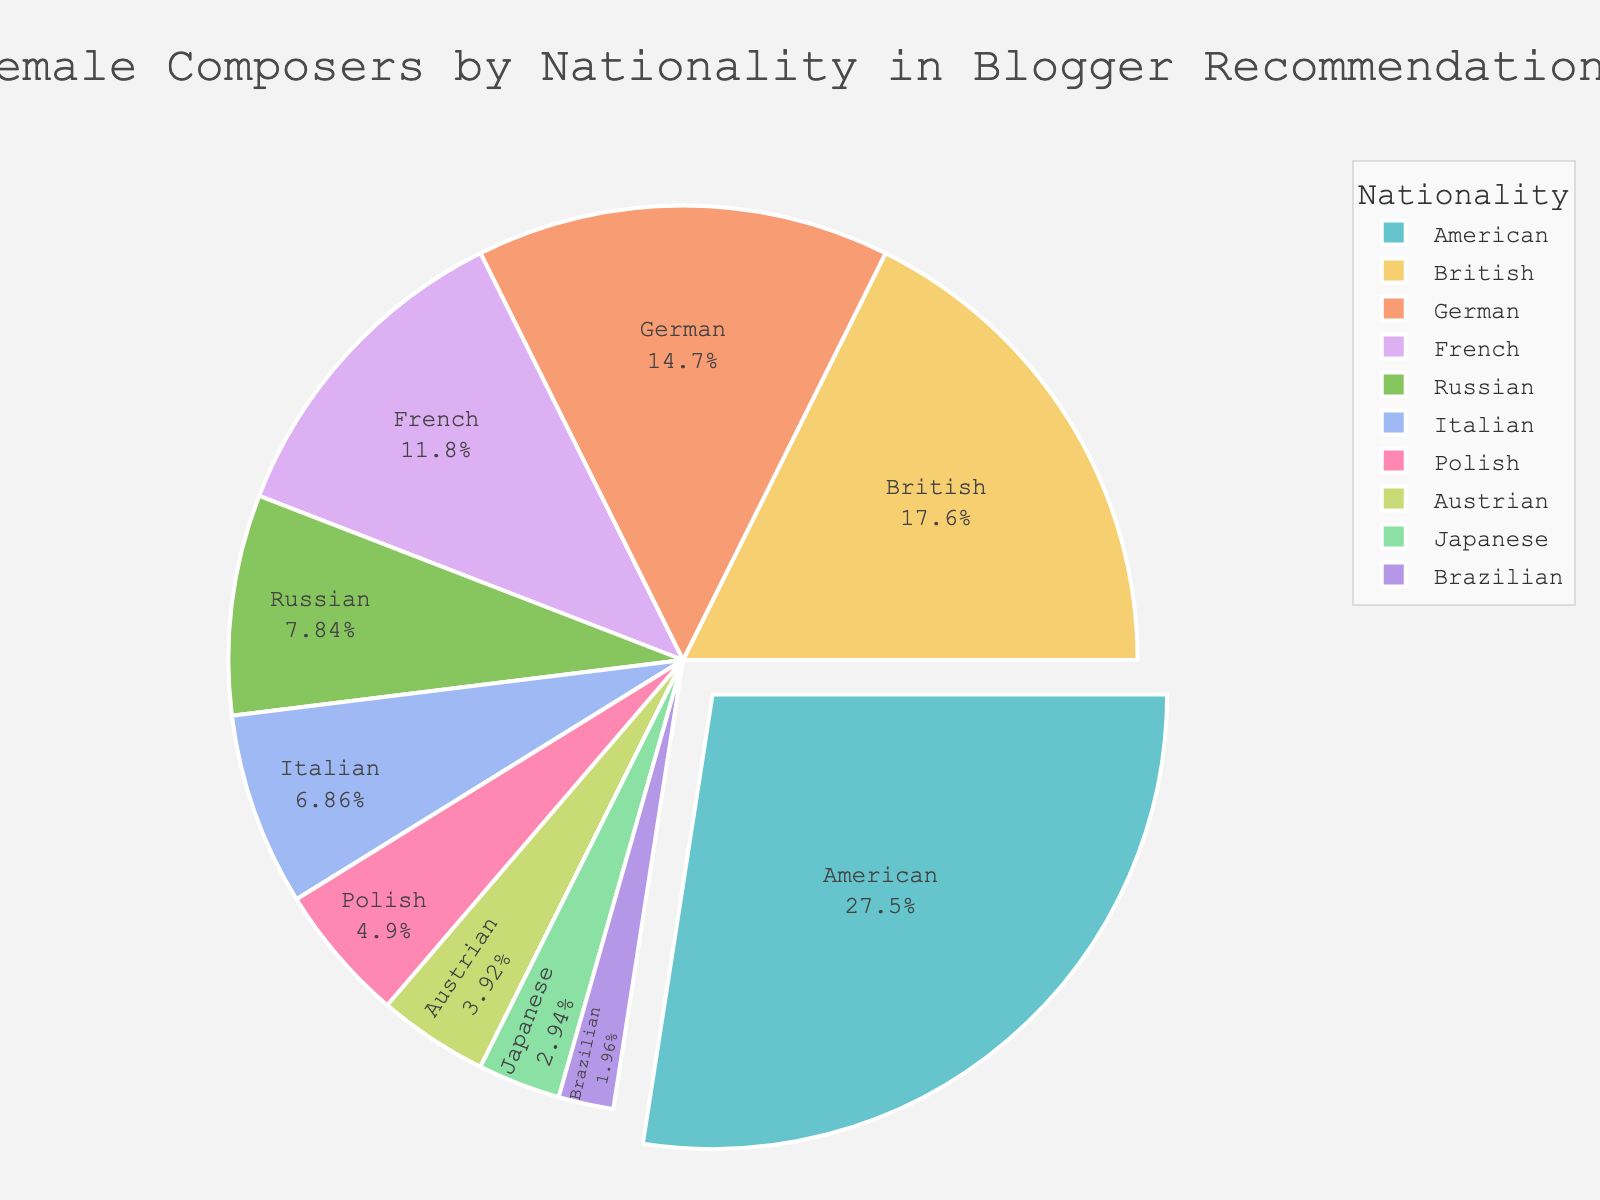How many nationalities together make up more than 60% of the recommendations? Add the percentages of the nationalities starting from the highest until the sum exceeds 60%. American (28%) + British (18%) + German (15%) = 61%
Answer: 3 Which nationality has the highest percentage of female composers in the recommendations? Refer to the nationality with the largest segment in the pie chart. The nationality with 28% is American
Answer: American What is the percentage difference between German and French composers? Subtract the percentage of French composers from German composers. 15% - 12% = 3%
Answer: 3% Are there more Russian or Italian female composers recommended? Compare the percentages for Russian and Italian composers. Russian is 8%, and Italian is 7%; thus, Russian is larger
Answer: Russian What is the combined percentage of Polish, Austrian, Japanese, and Brazilian composers? Add the percentages of these four nationalities. 5% (Polish) + 4% (Austrian) + 3% (Japanese) + 2% (Brazilian) = 14%
Answer: 14% If you were to combine American and British composers, what percentage of the total would they represent? Add the percentages of American and British composers. 28% (American) + 18% (British) = 46%
Answer: 46% Which nationality has the smallest representation in the recommendations? Look for the nationality with the smallest segment in the pie chart. The smallest percentage is 2%, which is Brazilian
Answer: Brazilian What is the percentage range of the nationalities represented in the recommendations? Subtract the smallest percentage from the largest percentage. 28% (largest, American) - 2% (smallest, Brazilian) = 26%
Answer: 26% What is the average percentage of German, French, and Russian composers? Add their percentages and divide by the number of nationalities. (15% (German) + 12% (French) + 8% (Russian)) / 3 = 11.67%
Answer: 11.67% How much more significant is the percentage of British composers compared to Japanese composers? Subtract the percentage of Japanese composers from British composers. 18% (British) - 3% (Japanese) = 15%
Answer: 15% 